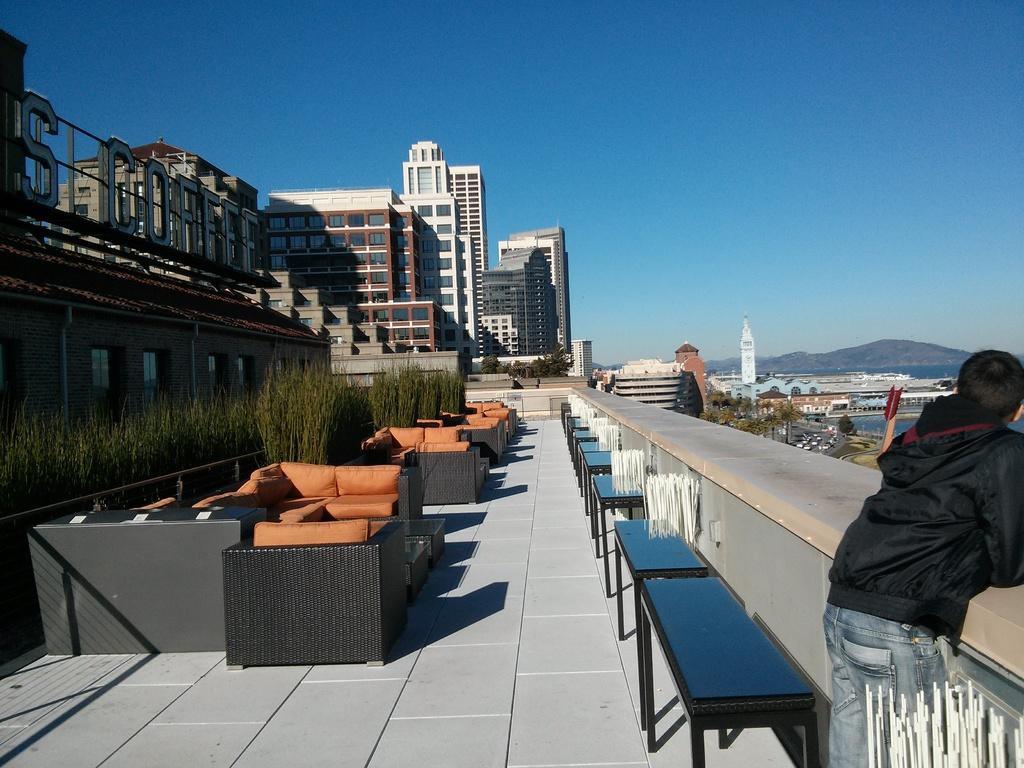How would you summarize this image in a sentence or two? In the right bottom a person is standing in front of the wall fence and next to that benches are there blue in color. In the left sofa orange in color and grass visible and buildings are visible. In the middle rights mountains, water and houses are visible. In the top sky blue in color is there. This image is taken during day time. 